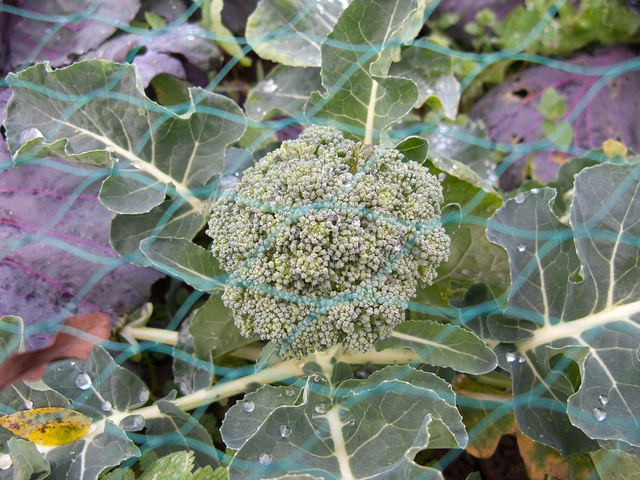Describe the objects in this image and their specific colors. I can see a broccoli in gray, darkgray, olive, and lightgray tones in this image. 